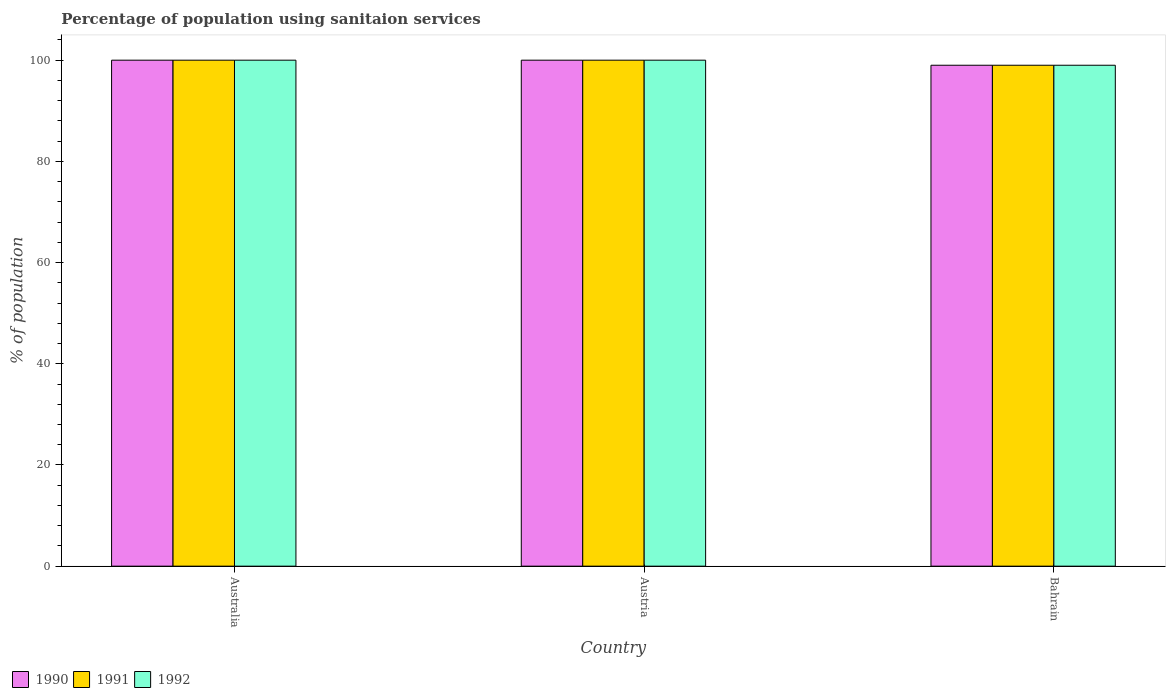How many groups of bars are there?
Give a very brief answer. 3. Are the number of bars per tick equal to the number of legend labels?
Offer a terse response. Yes. Are the number of bars on each tick of the X-axis equal?
Your answer should be compact. Yes. What is the label of the 1st group of bars from the left?
Offer a very short reply. Australia. In how many cases, is the number of bars for a given country not equal to the number of legend labels?
Ensure brevity in your answer.  0. What is the percentage of population using sanitaion services in 1990 in Australia?
Provide a succinct answer. 100. Across all countries, what is the minimum percentage of population using sanitaion services in 1992?
Provide a short and direct response. 99. In which country was the percentage of population using sanitaion services in 1990 maximum?
Your answer should be very brief. Australia. In which country was the percentage of population using sanitaion services in 1990 minimum?
Make the answer very short. Bahrain. What is the total percentage of population using sanitaion services in 1991 in the graph?
Offer a very short reply. 299. What is the difference between the percentage of population using sanitaion services in 1990 in Australia and the percentage of population using sanitaion services in 1992 in Bahrain?
Your answer should be very brief. 1. What is the average percentage of population using sanitaion services in 1992 per country?
Offer a terse response. 99.67. In how many countries, is the percentage of population using sanitaion services in 1991 greater than 44 %?
Give a very brief answer. 3. What is the ratio of the percentage of population using sanitaion services in 1991 in Australia to that in Bahrain?
Ensure brevity in your answer.  1.01. Is the percentage of population using sanitaion services in 1992 in Australia less than that in Austria?
Provide a succinct answer. No. In how many countries, is the percentage of population using sanitaion services in 1991 greater than the average percentage of population using sanitaion services in 1991 taken over all countries?
Give a very brief answer. 2. Is the sum of the percentage of population using sanitaion services in 1990 in Australia and Austria greater than the maximum percentage of population using sanitaion services in 1992 across all countries?
Provide a succinct answer. Yes. What does the 1st bar from the left in Bahrain represents?
Your response must be concise. 1990. What does the 3rd bar from the right in Austria represents?
Your answer should be compact. 1990. Is it the case that in every country, the sum of the percentage of population using sanitaion services in 1991 and percentage of population using sanitaion services in 1990 is greater than the percentage of population using sanitaion services in 1992?
Your response must be concise. Yes. Are all the bars in the graph horizontal?
Your answer should be compact. No. Does the graph contain any zero values?
Your response must be concise. No. Does the graph contain grids?
Your answer should be very brief. No. Where does the legend appear in the graph?
Provide a short and direct response. Bottom left. What is the title of the graph?
Ensure brevity in your answer.  Percentage of population using sanitaion services. Does "1990" appear as one of the legend labels in the graph?
Keep it short and to the point. Yes. What is the label or title of the X-axis?
Offer a terse response. Country. What is the label or title of the Y-axis?
Provide a succinct answer. % of population. What is the % of population of 1992 in Australia?
Ensure brevity in your answer.  100. What is the % of population in 1991 in Austria?
Give a very brief answer. 100. What is the % of population of 1992 in Austria?
Ensure brevity in your answer.  100. Across all countries, what is the maximum % of population of 1990?
Provide a succinct answer. 100. Across all countries, what is the maximum % of population of 1991?
Your answer should be very brief. 100. Across all countries, what is the minimum % of population in 1991?
Ensure brevity in your answer.  99. Across all countries, what is the minimum % of population of 1992?
Provide a succinct answer. 99. What is the total % of population of 1990 in the graph?
Offer a very short reply. 299. What is the total % of population in 1991 in the graph?
Make the answer very short. 299. What is the total % of population in 1992 in the graph?
Keep it short and to the point. 299. What is the difference between the % of population in 1990 in Australia and that in Austria?
Keep it short and to the point. 0. What is the difference between the % of population in 1991 in Australia and that in Austria?
Provide a succinct answer. 0. What is the difference between the % of population of 1990 in Australia and that in Bahrain?
Provide a short and direct response. 1. What is the difference between the % of population in 1991 in Australia and that in Bahrain?
Offer a very short reply. 1. What is the difference between the % of population of 1992 in Austria and that in Bahrain?
Give a very brief answer. 1. What is the difference between the % of population of 1990 in Australia and the % of population of 1992 in Austria?
Offer a terse response. 0. What is the difference between the % of population in 1990 in Australia and the % of population in 1991 in Bahrain?
Make the answer very short. 1. What is the difference between the % of population in 1990 in Australia and the % of population in 1992 in Bahrain?
Ensure brevity in your answer.  1. What is the difference between the % of population of 1991 in Australia and the % of population of 1992 in Bahrain?
Keep it short and to the point. 1. What is the difference between the % of population of 1990 in Austria and the % of population of 1991 in Bahrain?
Your answer should be compact. 1. What is the difference between the % of population of 1990 in Austria and the % of population of 1992 in Bahrain?
Your answer should be very brief. 1. What is the average % of population in 1990 per country?
Give a very brief answer. 99.67. What is the average % of population of 1991 per country?
Give a very brief answer. 99.67. What is the average % of population of 1992 per country?
Make the answer very short. 99.67. What is the difference between the % of population in 1990 and % of population in 1991 in Bahrain?
Offer a very short reply. 0. What is the difference between the % of population of 1990 and % of population of 1992 in Bahrain?
Offer a terse response. 0. What is the difference between the % of population of 1991 and % of population of 1992 in Bahrain?
Keep it short and to the point. 0. What is the ratio of the % of population in 1990 in Australia to that in Austria?
Ensure brevity in your answer.  1. What is the ratio of the % of population of 1992 in Australia to that in Austria?
Offer a terse response. 1. What is the ratio of the % of population in 1990 in Austria to that in Bahrain?
Your response must be concise. 1.01. What is the difference between the highest and the second highest % of population of 1992?
Ensure brevity in your answer.  0. What is the difference between the highest and the lowest % of population in 1990?
Provide a succinct answer. 1. 